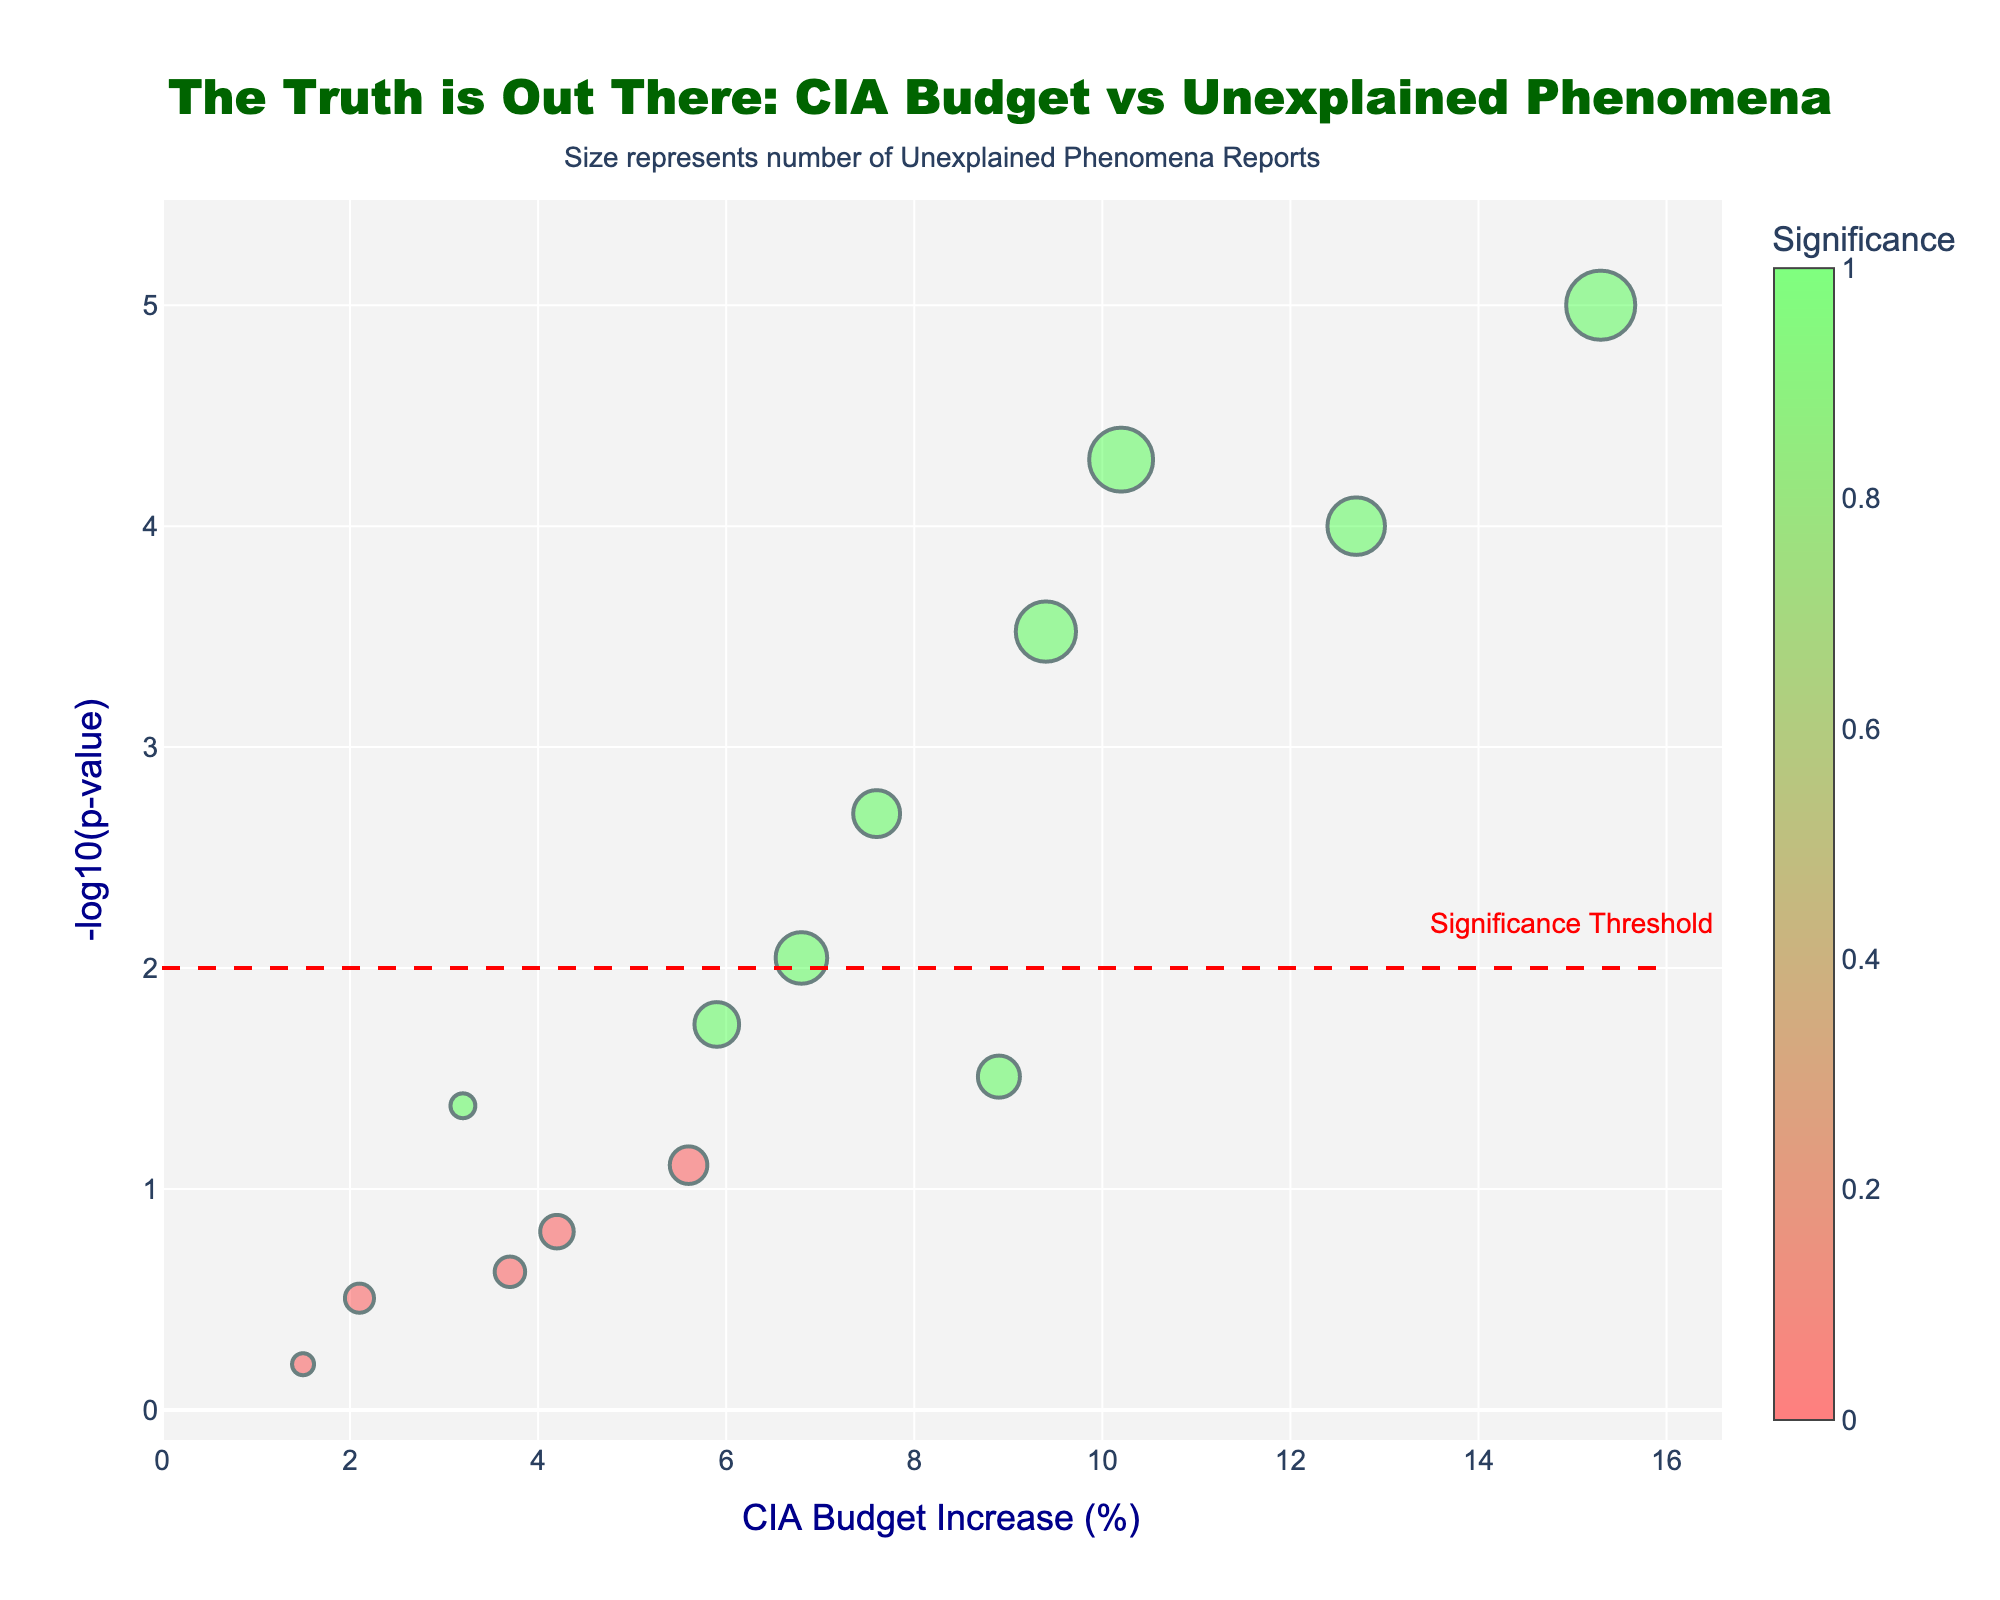Which year had the highest CIA budget increase? By looking at the horizontal axis (CIA Budget Increase (%)), the highest point corresponds to the year 2003 with a budget increase of 15.3%.
Answer: 2003 How many years had significant results according to the plot? Significant results are indicated by the color scale where significant points are highlighted. By examining the plot, there are 9 year points colored differently that fall above the dashed red "Significance Threshold" line.
Answer: 9 Which year saw the highest number of unexplained phenomena reports? The size of the markers represents the number of unexplained phenomena reports. The largest marker corresponds to the year 2003 with 3456 reports.
Answer: 2003 What is the significance threshold depicted in the plot? The red dashed line indicates the significance threshold on the y-axis. The label next to the line states its value, which is 2 on the -log10(p-value) scale.
Answer: 2 Which year had the smallest unexplained phenomena report yet was still significant? We need to look for the smallest marker among the significant points (above the significance threshold line) and its corresponding value, which is in 1997 with 1245 reports.
Answer: 1997 How many years have a p-value lower than 0.05? In a volcano plot, this translates to points above the -log10(p-value) of about 1.3. By checking the points above this threshold, there are 8 years.
Answer: 8 Which years had non-significant results? Non-significant points fall below the significance threshold and are not colored as significant. These points are from the years 2009, 2013, 1999, 2007, and 2011.
Answer: 2009, 2013, 1999, 2007, 2011 What is the p-value for the year 2021? By hovering over the year 2021 on the plot, its hovertext shows a p-value of 0.009.
Answer: 0.009 Was there any significant year with less than a 3% increase in CIA budget? Significant years are above the dashed line and have different coloring. By checking the horizontal axis, the year 1997 had a CIA budget increase of 3.2%, which is greater than 3%. Thus, no significant years had less than a 3% increase in CIA budget.
Answer: No What is the range of CIA budget increases from the data presented in the plot? Looking at the x-axis values, the smallest increase is 1.5%, and the largest is 15.3%. So, the range is 15.3% - 1.5% = 13.8%.
Answer: 13.8% 